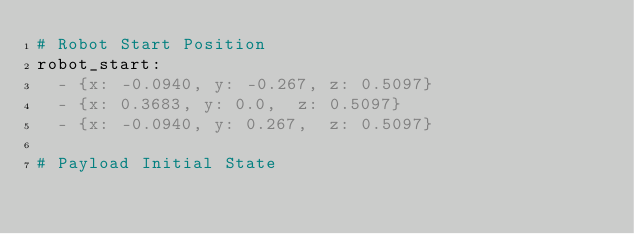<code> <loc_0><loc_0><loc_500><loc_500><_YAML_># Robot Start Position
robot_start: 
  - {x: -0.0940, y: -0.267, z: 0.5097}
  - {x: 0.3683, y: 0.0,  z: 0.5097}
  - {x: -0.0940, y: 0.267,  z: 0.5097}

# Payload Initial State</code> 